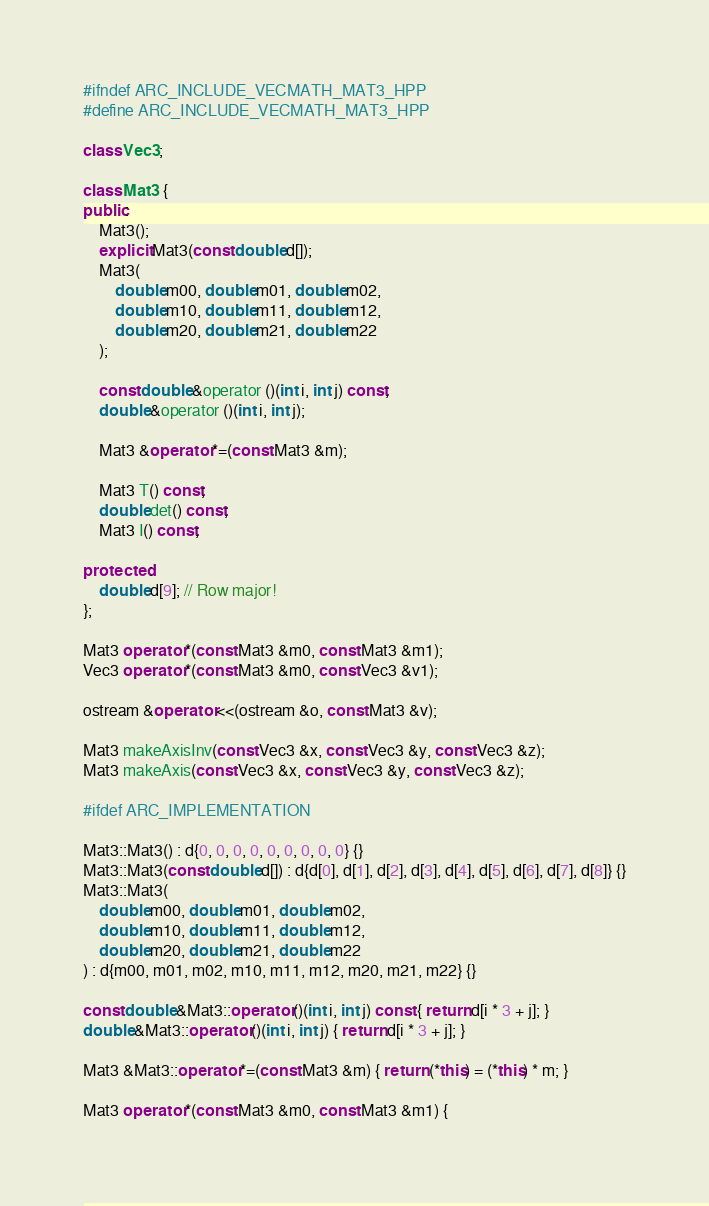<code> <loc_0><loc_0><loc_500><loc_500><_C++_>#ifndef ARC_INCLUDE_VECMATH_MAT3_HPP
#define ARC_INCLUDE_VECMATH_MAT3_HPP

class Vec3;

class Mat3 {
public:
    Mat3();
    explicit Mat3(const double d[]);
    Mat3(
        double m00, double m01, double m02,
        double m10, double m11, double m12,
        double m20, double m21, double m22
    );

    const double &operator ()(int i, int j) const;
    double &operator ()(int i, int j);

    Mat3 &operator *=(const Mat3 &m);

    Mat3 T() const;
    double det() const;
    Mat3 I() const;

protected:
    double d[9]; // Row major!
};

Mat3 operator *(const Mat3 &m0, const Mat3 &m1);
Vec3 operator *(const Mat3 &m0, const Vec3 &v1);

ostream &operator <<(ostream &o, const Mat3 &v);

Mat3 makeAxisInv(const Vec3 &x, const Vec3 &y, const Vec3 &z);
Mat3 makeAxis(const Vec3 &x, const Vec3 &y, const Vec3 &z);

#ifdef ARC_IMPLEMENTATION

Mat3::Mat3() : d{0, 0, 0, 0, 0, 0, 0, 0, 0} {}
Mat3::Mat3(const double d[]) : d{d[0], d[1], d[2], d[3], d[4], d[5], d[6], d[7], d[8]} {}
Mat3::Mat3(
    double m00, double m01, double m02,
    double m10, double m11, double m12,
    double m20, double m21, double m22
) : d{m00, m01, m02, m10, m11, m12, m20, m21, m22} {}

const double &Mat3::operator ()(int i, int j) const { return d[i * 3 + j]; }
double &Mat3::operator ()(int i, int j) { return d[i * 3 + j]; }

Mat3 &Mat3::operator *=(const Mat3 &m) { return (*this) = (*this) * m; }

Mat3 operator *(const Mat3 &m0, const Mat3 &m1) {</code> 